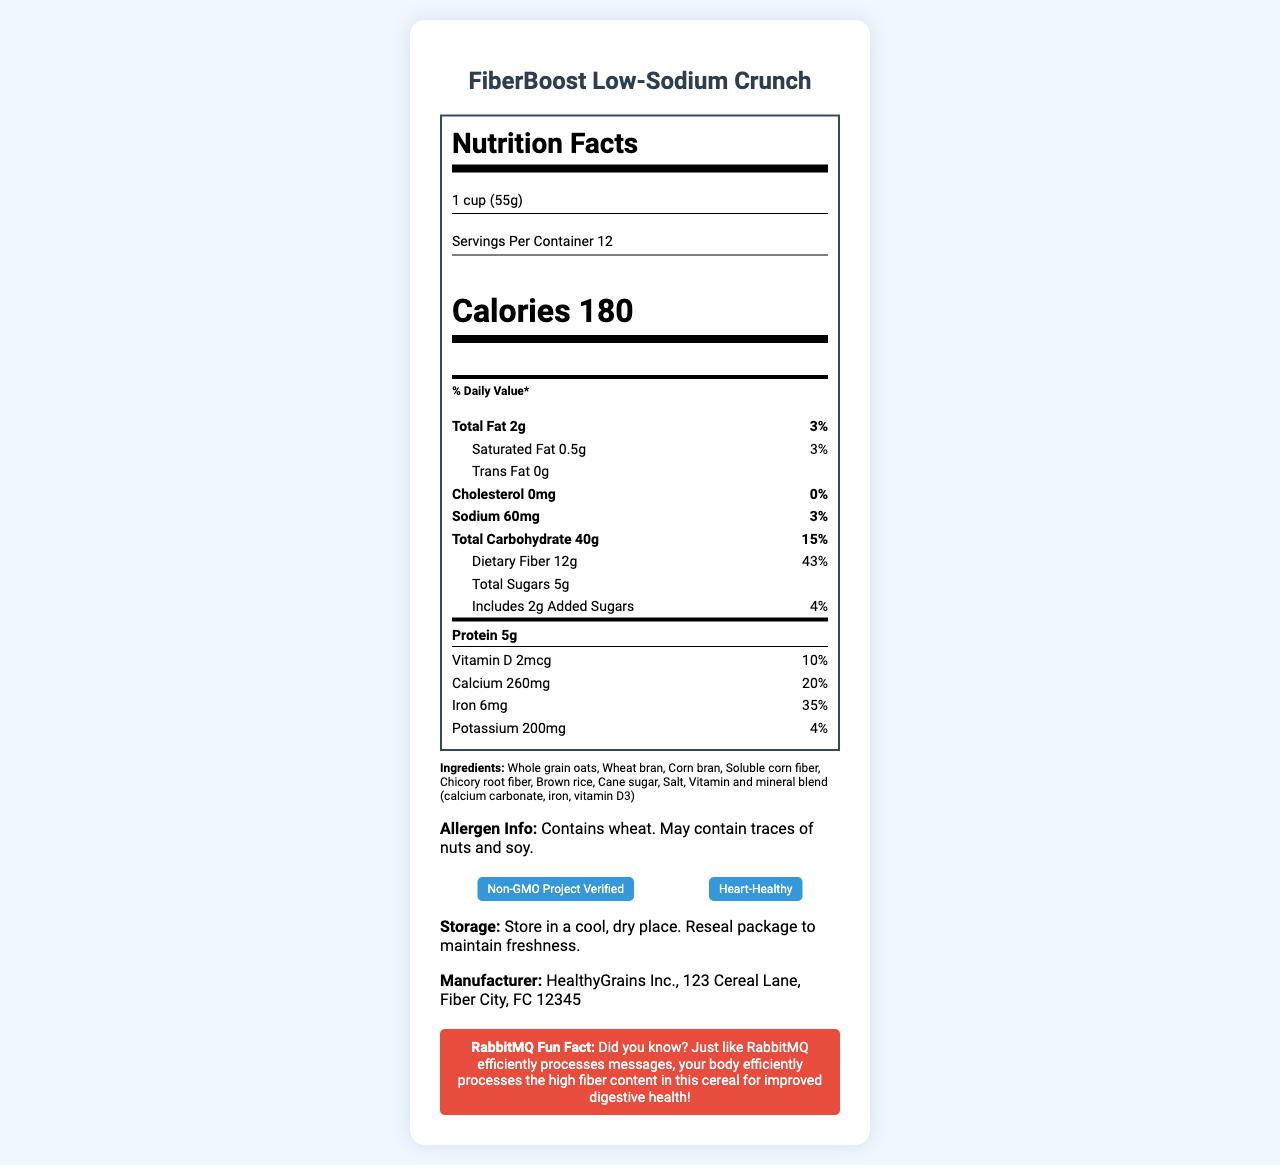what is the serving size of the breakfast cereal? The serving size is stated as 1 cup, which is equivalent to 55 grams.
Answer: 1 cup (55g) how many calories are there per serving? The calories per serving are explicitly stated in the document as 180.
Answer: 180 calories what is the sodium content per serving? The document mentions that each serving contains 60 milligrams of sodium.
Answer: 60 milligrams what percentage of daily value does the dietary fiber provide? According to the document, the dietary fiber content is 12 grams, which accounts for 43% of the daily value.
Answer: 43% how much protein is there in each serving? The protein content per serving is listed as 5 grams in the document.
Answer: 5 grams which vitamin or mineral provides the highest percentage of daily value? A. Vitamin D B. Calcium C. Iron D. Potassium The document states that Iron provides 35% of the daily value, which is the highest among the listed vitamins and minerals.
Answer: C. Iron how many grams of total sugars are there per serving? The total sugar content per serving is specified as 5 grams.
Answer: 5 grams what certifications does the cereal have? A. Gluten-Free B. Non-GMO Project Verified C. Organic D. Heart-Healthy E. Vegan The document lists the certifications as "Non-GMO Project Verified" and "Heart-Healthy".
Answer: B. Non-GMO Project Verified and D. Heart-Healthy is there any trans fat in this cereal? The document states that the cereal contains 0 grams of trans fat.
Answer: No summarize the main idea of the Nutrition Facts Label. The document provides comprehensive nutrition facts for the cereal, highlighting its low-sodium and high-fiber content, along with other nutritional details, ingredients, allergen information, storage instructions, and manufacturer details.
Answer: FiberBoost Low-Sodium Crunch is a low-sodium, high-fiber breakfast cereal with detailed nutritional information per serving, including low fat, moderate calories, and significant amounts of calcium and iron. who is the manufacturer? The document mentions that the manufacturer is HealthyGrains Inc.
Answer: HealthyGrains Inc. is the cereal high in dietary fiber? The dietary fiber content is 12 grams per serving, which is 43% of the daily value, indicating that it is high in dietary fiber.
Answer: Yes what is the main ingredient in the cereal? The first ingredient listed, indicating it is the main ingredient, is whole grain oats.
Answer: Whole grain oats does the cereal contain any allergens? The allergen information states that it contains wheat and may contain traces of nuts and soy.
Answer: Yes how many servings are in one container? The document states there are 12 servings per container.
Answer: 12 servings how much vitamin D is provided per serving? The vitamin D content per serving is listed as 2 micrograms.
Answer: 2 micrograms what is the address of the manufacturer? The manufacturer’s address provided is 123 Cereal Lane, Fiber City, FC 12345.
Answer: 123 Cereal Lane, Fiber City, FC 12345 what is the percentage of daily value for saturated fat? The document states that the saturated fat content per serving is 0.5 grams, which is 3% of the daily value.
Answer: 3% what is the website of the manufacturer? The manufacturer's website is listed as www.healthygrains.com.
Answer: www.healthygrains.com does the cereal contain high fructose corn syrup? The document does not provide explicit information about the presence of high fructose corn syrup.
Answer: Cannot be determined 